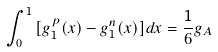Convert formula to latex. <formula><loc_0><loc_0><loc_500><loc_500>\int ^ { 1 } _ { 0 } { [ g _ { 1 } ^ { p } ( x ) - g _ { 1 } ^ { n } ( x ) ] d x } = \frac { 1 } { 6 } g _ { A }</formula> 